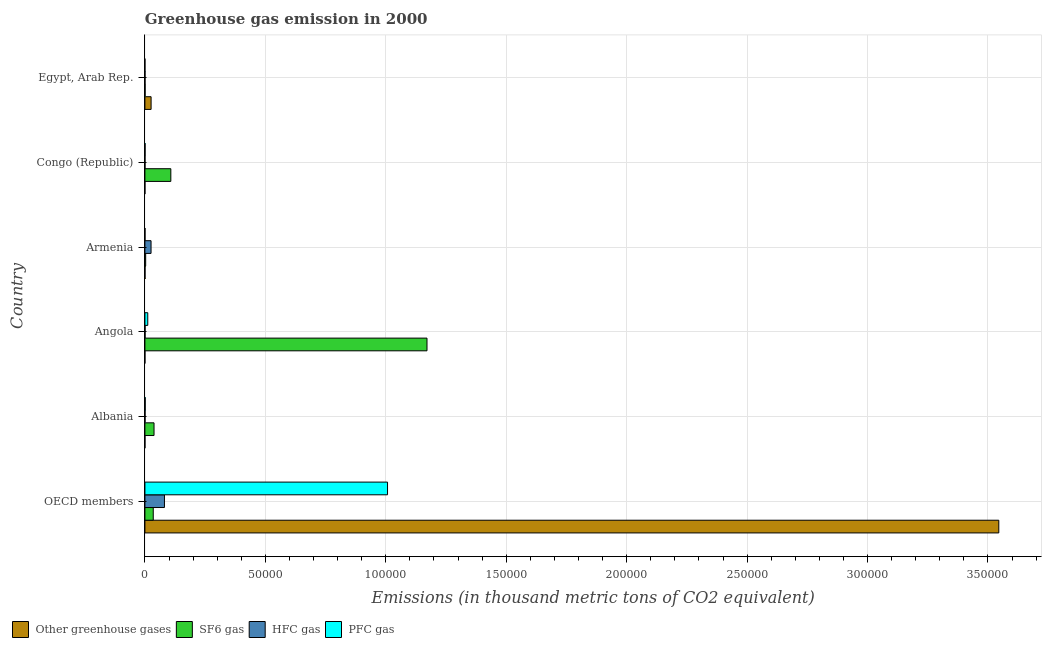How many different coloured bars are there?
Your answer should be very brief. 4. How many groups of bars are there?
Make the answer very short. 6. What is the label of the 4th group of bars from the top?
Give a very brief answer. Angola. What is the emission of hfc gas in Angola?
Offer a very short reply. 63. Across all countries, what is the maximum emission of greenhouse gases?
Your response must be concise. 3.54e+05. Across all countries, what is the minimum emission of sf6 gas?
Your answer should be very brief. 81.4. In which country was the emission of sf6 gas maximum?
Ensure brevity in your answer.  Angola. In which country was the emission of hfc gas minimum?
Make the answer very short. Congo (Republic). What is the total emission of hfc gas in the graph?
Give a very brief answer. 1.08e+04. What is the difference between the emission of hfc gas in Armenia and that in OECD members?
Offer a terse response. -5561.5. What is the difference between the emission of greenhouse gases in Angola and the emission of hfc gas in Egypt, Arab Rep.?
Your response must be concise. -40.7. What is the average emission of sf6 gas per country?
Offer a terse response. 2.26e+04. What is the difference between the emission of pfc gas and emission of hfc gas in Angola?
Offer a terse response. 1118.4. What is the ratio of the emission of sf6 gas in Armenia to that in Congo (Republic)?
Offer a very short reply. 0.03. Is the emission of hfc gas in Angola less than that in Congo (Republic)?
Give a very brief answer. No. Is the difference between the emission of pfc gas in Egypt, Arab Rep. and OECD members greater than the difference between the emission of sf6 gas in Egypt, Arab Rep. and OECD members?
Give a very brief answer. No. What is the difference between the highest and the second highest emission of sf6 gas?
Give a very brief answer. 1.06e+05. What is the difference between the highest and the lowest emission of sf6 gas?
Keep it short and to the point. 1.17e+05. In how many countries, is the emission of greenhouse gases greater than the average emission of greenhouse gases taken over all countries?
Provide a short and direct response. 1. Is the sum of the emission of sf6 gas in Congo (Republic) and Egypt, Arab Rep. greater than the maximum emission of hfc gas across all countries?
Your response must be concise. Yes. What does the 3rd bar from the top in Congo (Republic) represents?
Offer a very short reply. SF6 gas. What does the 4th bar from the bottom in Angola represents?
Provide a short and direct response. PFC gas. Is it the case that in every country, the sum of the emission of greenhouse gases and emission of sf6 gas is greater than the emission of hfc gas?
Offer a terse response. No. How many bars are there?
Provide a succinct answer. 24. Are the values on the major ticks of X-axis written in scientific E-notation?
Offer a very short reply. No. Does the graph contain any zero values?
Give a very brief answer. No. Does the graph contain grids?
Give a very brief answer. Yes. What is the title of the graph?
Give a very brief answer. Greenhouse gas emission in 2000. What is the label or title of the X-axis?
Keep it short and to the point. Emissions (in thousand metric tons of CO2 equivalent). What is the Emissions (in thousand metric tons of CO2 equivalent) in Other greenhouse gases in OECD members?
Your response must be concise. 3.54e+05. What is the Emissions (in thousand metric tons of CO2 equivalent) of SF6 gas in OECD members?
Offer a terse response. 3457.7. What is the Emissions (in thousand metric tons of CO2 equivalent) of HFC gas in OECD members?
Make the answer very short. 8107.2. What is the Emissions (in thousand metric tons of CO2 equivalent) in PFC gas in OECD members?
Make the answer very short. 1.01e+05. What is the Emissions (in thousand metric tons of CO2 equivalent) in SF6 gas in Albania?
Your answer should be compact. 3781.9. What is the Emissions (in thousand metric tons of CO2 equivalent) of HFC gas in Albania?
Your response must be concise. 60.5. What is the Emissions (in thousand metric tons of CO2 equivalent) in PFC gas in Albania?
Provide a succinct answer. 121.8. What is the Emissions (in thousand metric tons of CO2 equivalent) in Other greenhouse gases in Angola?
Offer a very short reply. 0.7. What is the Emissions (in thousand metric tons of CO2 equivalent) of SF6 gas in Angola?
Your response must be concise. 1.17e+05. What is the Emissions (in thousand metric tons of CO2 equivalent) in HFC gas in Angola?
Make the answer very short. 63. What is the Emissions (in thousand metric tons of CO2 equivalent) of PFC gas in Angola?
Keep it short and to the point. 1181.4. What is the Emissions (in thousand metric tons of CO2 equivalent) in SF6 gas in Armenia?
Keep it short and to the point. 311.4. What is the Emissions (in thousand metric tons of CO2 equivalent) in HFC gas in Armenia?
Offer a terse response. 2545.7. What is the Emissions (in thousand metric tons of CO2 equivalent) of PFC gas in Armenia?
Ensure brevity in your answer.  32.8. What is the Emissions (in thousand metric tons of CO2 equivalent) in SF6 gas in Congo (Republic)?
Provide a succinct answer. 1.08e+04. What is the Emissions (in thousand metric tons of CO2 equivalent) in HFC gas in Congo (Republic)?
Provide a short and direct response. 25.2. What is the Emissions (in thousand metric tons of CO2 equivalent) of PFC gas in Congo (Republic)?
Offer a very short reply. 63. What is the Emissions (in thousand metric tons of CO2 equivalent) of Other greenhouse gases in Egypt, Arab Rep.?
Your answer should be very brief. 2565.6. What is the Emissions (in thousand metric tons of CO2 equivalent) in SF6 gas in Egypt, Arab Rep.?
Give a very brief answer. 81.4. What is the Emissions (in thousand metric tons of CO2 equivalent) in HFC gas in Egypt, Arab Rep.?
Your answer should be very brief. 41.4. Across all countries, what is the maximum Emissions (in thousand metric tons of CO2 equivalent) of Other greenhouse gases?
Provide a succinct answer. 3.54e+05. Across all countries, what is the maximum Emissions (in thousand metric tons of CO2 equivalent) in SF6 gas?
Provide a succinct answer. 1.17e+05. Across all countries, what is the maximum Emissions (in thousand metric tons of CO2 equivalent) of HFC gas?
Ensure brevity in your answer.  8107.2. Across all countries, what is the maximum Emissions (in thousand metric tons of CO2 equivalent) in PFC gas?
Your response must be concise. 1.01e+05. Across all countries, what is the minimum Emissions (in thousand metric tons of CO2 equivalent) of SF6 gas?
Your answer should be compact. 81.4. Across all countries, what is the minimum Emissions (in thousand metric tons of CO2 equivalent) of HFC gas?
Keep it short and to the point. 25.2. What is the total Emissions (in thousand metric tons of CO2 equivalent) of Other greenhouse gases in the graph?
Offer a terse response. 3.57e+05. What is the total Emissions (in thousand metric tons of CO2 equivalent) in SF6 gas in the graph?
Provide a succinct answer. 1.35e+05. What is the total Emissions (in thousand metric tons of CO2 equivalent) of HFC gas in the graph?
Make the answer very short. 1.08e+04. What is the total Emissions (in thousand metric tons of CO2 equivalent) of PFC gas in the graph?
Give a very brief answer. 1.02e+05. What is the difference between the Emissions (in thousand metric tons of CO2 equivalent) of Other greenhouse gases in OECD members and that in Albania?
Make the answer very short. 3.54e+05. What is the difference between the Emissions (in thousand metric tons of CO2 equivalent) in SF6 gas in OECD members and that in Albania?
Offer a very short reply. -324.2. What is the difference between the Emissions (in thousand metric tons of CO2 equivalent) in HFC gas in OECD members and that in Albania?
Offer a terse response. 8046.7. What is the difference between the Emissions (in thousand metric tons of CO2 equivalent) in PFC gas in OECD members and that in Albania?
Keep it short and to the point. 1.01e+05. What is the difference between the Emissions (in thousand metric tons of CO2 equivalent) of Other greenhouse gases in OECD members and that in Angola?
Give a very brief answer. 3.54e+05. What is the difference between the Emissions (in thousand metric tons of CO2 equivalent) in SF6 gas in OECD members and that in Angola?
Offer a very short reply. -1.14e+05. What is the difference between the Emissions (in thousand metric tons of CO2 equivalent) in HFC gas in OECD members and that in Angola?
Ensure brevity in your answer.  8044.2. What is the difference between the Emissions (in thousand metric tons of CO2 equivalent) in PFC gas in OECD members and that in Angola?
Your answer should be compact. 9.95e+04. What is the difference between the Emissions (in thousand metric tons of CO2 equivalent) in Other greenhouse gases in OECD members and that in Armenia?
Give a very brief answer. 3.54e+05. What is the difference between the Emissions (in thousand metric tons of CO2 equivalent) in SF6 gas in OECD members and that in Armenia?
Keep it short and to the point. 3146.3. What is the difference between the Emissions (in thousand metric tons of CO2 equivalent) of HFC gas in OECD members and that in Armenia?
Give a very brief answer. 5561.5. What is the difference between the Emissions (in thousand metric tons of CO2 equivalent) of PFC gas in OECD members and that in Armenia?
Provide a short and direct response. 1.01e+05. What is the difference between the Emissions (in thousand metric tons of CO2 equivalent) of Other greenhouse gases in OECD members and that in Congo (Republic)?
Give a very brief answer. 3.54e+05. What is the difference between the Emissions (in thousand metric tons of CO2 equivalent) of SF6 gas in OECD members and that in Congo (Republic)?
Your answer should be compact. -7295.9. What is the difference between the Emissions (in thousand metric tons of CO2 equivalent) in HFC gas in OECD members and that in Congo (Republic)?
Your answer should be very brief. 8082. What is the difference between the Emissions (in thousand metric tons of CO2 equivalent) in PFC gas in OECD members and that in Congo (Republic)?
Offer a very short reply. 1.01e+05. What is the difference between the Emissions (in thousand metric tons of CO2 equivalent) in Other greenhouse gases in OECD members and that in Egypt, Arab Rep.?
Offer a very short reply. 3.52e+05. What is the difference between the Emissions (in thousand metric tons of CO2 equivalent) in SF6 gas in OECD members and that in Egypt, Arab Rep.?
Offer a very short reply. 3376.3. What is the difference between the Emissions (in thousand metric tons of CO2 equivalent) in HFC gas in OECD members and that in Egypt, Arab Rep.?
Keep it short and to the point. 8065.8. What is the difference between the Emissions (in thousand metric tons of CO2 equivalent) in PFC gas in OECD members and that in Egypt, Arab Rep.?
Give a very brief answer. 1.01e+05. What is the difference between the Emissions (in thousand metric tons of CO2 equivalent) of SF6 gas in Albania and that in Angola?
Give a very brief answer. -1.13e+05. What is the difference between the Emissions (in thousand metric tons of CO2 equivalent) of PFC gas in Albania and that in Angola?
Make the answer very short. -1059.6. What is the difference between the Emissions (in thousand metric tons of CO2 equivalent) of Other greenhouse gases in Albania and that in Armenia?
Your answer should be compact. -26.5. What is the difference between the Emissions (in thousand metric tons of CO2 equivalent) in SF6 gas in Albania and that in Armenia?
Give a very brief answer. 3470.5. What is the difference between the Emissions (in thousand metric tons of CO2 equivalent) of HFC gas in Albania and that in Armenia?
Keep it short and to the point. -2485.2. What is the difference between the Emissions (in thousand metric tons of CO2 equivalent) in PFC gas in Albania and that in Armenia?
Keep it short and to the point. 89. What is the difference between the Emissions (in thousand metric tons of CO2 equivalent) in SF6 gas in Albania and that in Congo (Republic)?
Your answer should be very brief. -6971.7. What is the difference between the Emissions (in thousand metric tons of CO2 equivalent) of HFC gas in Albania and that in Congo (Republic)?
Keep it short and to the point. 35.3. What is the difference between the Emissions (in thousand metric tons of CO2 equivalent) in PFC gas in Albania and that in Congo (Republic)?
Give a very brief answer. 58.8. What is the difference between the Emissions (in thousand metric tons of CO2 equivalent) in Other greenhouse gases in Albania and that in Egypt, Arab Rep.?
Keep it short and to the point. -2550.1. What is the difference between the Emissions (in thousand metric tons of CO2 equivalent) in SF6 gas in Albania and that in Egypt, Arab Rep.?
Make the answer very short. 3700.5. What is the difference between the Emissions (in thousand metric tons of CO2 equivalent) of PFC gas in Albania and that in Egypt, Arab Rep.?
Offer a terse response. 118.3. What is the difference between the Emissions (in thousand metric tons of CO2 equivalent) in Other greenhouse gases in Angola and that in Armenia?
Ensure brevity in your answer.  -41.3. What is the difference between the Emissions (in thousand metric tons of CO2 equivalent) of SF6 gas in Angola and that in Armenia?
Provide a short and direct response. 1.17e+05. What is the difference between the Emissions (in thousand metric tons of CO2 equivalent) in HFC gas in Angola and that in Armenia?
Make the answer very short. -2482.7. What is the difference between the Emissions (in thousand metric tons of CO2 equivalent) of PFC gas in Angola and that in Armenia?
Provide a short and direct response. 1148.6. What is the difference between the Emissions (in thousand metric tons of CO2 equivalent) of SF6 gas in Angola and that in Congo (Republic)?
Your answer should be very brief. 1.06e+05. What is the difference between the Emissions (in thousand metric tons of CO2 equivalent) in HFC gas in Angola and that in Congo (Republic)?
Ensure brevity in your answer.  37.8. What is the difference between the Emissions (in thousand metric tons of CO2 equivalent) of PFC gas in Angola and that in Congo (Republic)?
Make the answer very short. 1118.4. What is the difference between the Emissions (in thousand metric tons of CO2 equivalent) in Other greenhouse gases in Angola and that in Egypt, Arab Rep.?
Provide a succinct answer. -2564.9. What is the difference between the Emissions (in thousand metric tons of CO2 equivalent) in SF6 gas in Angola and that in Egypt, Arab Rep.?
Give a very brief answer. 1.17e+05. What is the difference between the Emissions (in thousand metric tons of CO2 equivalent) of HFC gas in Angola and that in Egypt, Arab Rep.?
Your answer should be very brief. 21.6. What is the difference between the Emissions (in thousand metric tons of CO2 equivalent) in PFC gas in Angola and that in Egypt, Arab Rep.?
Your response must be concise. 1177.9. What is the difference between the Emissions (in thousand metric tons of CO2 equivalent) in Other greenhouse gases in Armenia and that in Congo (Republic)?
Ensure brevity in your answer.  41.2. What is the difference between the Emissions (in thousand metric tons of CO2 equivalent) of SF6 gas in Armenia and that in Congo (Republic)?
Offer a terse response. -1.04e+04. What is the difference between the Emissions (in thousand metric tons of CO2 equivalent) of HFC gas in Armenia and that in Congo (Republic)?
Offer a terse response. 2520.5. What is the difference between the Emissions (in thousand metric tons of CO2 equivalent) of PFC gas in Armenia and that in Congo (Republic)?
Make the answer very short. -30.2. What is the difference between the Emissions (in thousand metric tons of CO2 equivalent) of Other greenhouse gases in Armenia and that in Egypt, Arab Rep.?
Your answer should be very brief. -2523.6. What is the difference between the Emissions (in thousand metric tons of CO2 equivalent) of SF6 gas in Armenia and that in Egypt, Arab Rep.?
Your answer should be compact. 230. What is the difference between the Emissions (in thousand metric tons of CO2 equivalent) in HFC gas in Armenia and that in Egypt, Arab Rep.?
Offer a very short reply. 2504.3. What is the difference between the Emissions (in thousand metric tons of CO2 equivalent) of PFC gas in Armenia and that in Egypt, Arab Rep.?
Ensure brevity in your answer.  29.3. What is the difference between the Emissions (in thousand metric tons of CO2 equivalent) in Other greenhouse gases in Congo (Republic) and that in Egypt, Arab Rep.?
Provide a succinct answer. -2564.8. What is the difference between the Emissions (in thousand metric tons of CO2 equivalent) of SF6 gas in Congo (Republic) and that in Egypt, Arab Rep.?
Your answer should be compact. 1.07e+04. What is the difference between the Emissions (in thousand metric tons of CO2 equivalent) in HFC gas in Congo (Republic) and that in Egypt, Arab Rep.?
Give a very brief answer. -16.2. What is the difference between the Emissions (in thousand metric tons of CO2 equivalent) in PFC gas in Congo (Republic) and that in Egypt, Arab Rep.?
Provide a succinct answer. 59.5. What is the difference between the Emissions (in thousand metric tons of CO2 equivalent) in Other greenhouse gases in OECD members and the Emissions (in thousand metric tons of CO2 equivalent) in SF6 gas in Albania?
Your response must be concise. 3.51e+05. What is the difference between the Emissions (in thousand metric tons of CO2 equivalent) in Other greenhouse gases in OECD members and the Emissions (in thousand metric tons of CO2 equivalent) in HFC gas in Albania?
Offer a terse response. 3.54e+05. What is the difference between the Emissions (in thousand metric tons of CO2 equivalent) of Other greenhouse gases in OECD members and the Emissions (in thousand metric tons of CO2 equivalent) of PFC gas in Albania?
Make the answer very short. 3.54e+05. What is the difference between the Emissions (in thousand metric tons of CO2 equivalent) of SF6 gas in OECD members and the Emissions (in thousand metric tons of CO2 equivalent) of HFC gas in Albania?
Your answer should be compact. 3397.2. What is the difference between the Emissions (in thousand metric tons of CO2 equivalent) in SF6 gas in OECD members and the Emissions (in thousand metric tons of CO2 equivalent) in PFC gas in Albania?
Your answer should be compact. 3335.9. What is the difference between the Emissions (in thousand metric tons of CO2 equivalent) in HFC gas in OECD members and the Emissions (in thousand metric tons of CO2 equivalent) in PFC gas in Albania?
Offer a terse response. 7985.4. What is the difference between the Emissions (in thousand metric tons of CO2 equivalent) of Other greenhouse gases in OECD members and the Emissions (in thousand metric tons of CO2 equivalent) of SF6 gas in Angola?
Your answer should be very brief. 2.37e+05. What is the difference between the Emissions (in thousand metric tons of CO2 equivalent) in Other greenhouse gases in OECD members and the Emissions (in thousand metric tons of CO2 equivalent) in HFC gas in Angola?
Your response must be concise. 3.54e+05. What is the difference between the Emissions (in thousand metric tons of CO2 equivalent) in Other greenhouse gases in OECD members and the Emissions (in thousand metric tons of CO2 equivalent) in PFC gas in Angola?
Keep it short and to the point. 3.53e+05. What is the difference between the Emissions (in thousand metric tons of CO2 equivalent) in SF6 gas in OECD members and the Emissions (in thousand metric tons of CO2 equivalent) in HFC gas in Angola?
Keep it short and to the point. 3394.7. What is the difference between the Emissions (in thousand metric tons of CO2 equivalent) in SF6 gas in OECD members and the Emissions (in thousand metric tons of CO2 equivalent) in PFC gas in Angola?
Your answer should be very brief. 2276.3. What is the difference between the Emissions (in thousand metric tons of CO2 equivalent) of HFC gas in OECD members and the Emissions (in thousand metric tons of CO2 equivalent) of PFC gas in Angola?
Ensure brevity in your answer.  6925.8. What is the difference between the Emissions (in thousand metric tons of CO2 equivalent) in Other greenhouse gases in OECD members and the Emissions (in thousand metric tons of CO2 equivalent) in SF6 gas in Armenia?
Provide a succinct answer. 3.54e+05. What is the difference between the Emissions (in thousand metric tons of CO2 equivalent) in Other greenhouse gases in OECD members and the Emissions (in thousand metric tons of CO2 equivalent) in HFC gas in Armenia?
Your answer should be very brief. 3.52e+05. What is the difference between the Emissions (in thousand metric tons of CO2 equivalent) in Other greenhouse gases in OECD members and the Emissions (in thousand metric tons of CO2 equivalent) in PFC gas in Armenia?
Make the answer very short. 3.54e+05. What is the difference between the Emissions (in thousand metric tons of CO2 equivalent) in SF6 gas in OECD members and the Emissions (in thousand metric tons of CO2 equivalent) in HFC gas in Armenia?
Your response must be concise. 912. What is the difference between the Emissions (in thousand metric tons of CO2 equivalent) of SF6 gas in OECD members and the Emissions (in thousand metric tons of CO2 equivalent) of PFC gas in Armenia?
Provide a succinct answer. 3424.9. What is the difference between the Emissions (in thousand metric tons of CO2 equivalent) in HFC gas in OECD members and the Emissions (in thousand metric tons of CO2 equivalent) in PFC gas in Armenia?
Offer a terse response. 8074.4. What is the difference between the Emissions (in thousand metric tons of CO2 equivalent) in Other greenhouse gases in OECD members and the Emissions (in thousand metric tons of CO2 equivalent) in SF6 gas in Congo (Republic)?
Your answer should be compact. 3.44e+05. What is the difference between the Emissions (in thousand metric tons of CO2 equivalent) in Other greenhouse gases in OECD members and the Emissions (in thousand metric tons of CO2 equivalent) in HFC gas in Congo (Republic)?
Your answer should be very brief. 3.54e+05. What is the difference between the Emissions (in thousand metric tons of CO2 equivalent) of Other greenhouse gases in OECD members and the Emissions (in thousand metric tons of CO2 equivalent) of PFC gas in Congo (Republic)?
Your response must be concise. 3.54e+05. What is the difference between the Emissions (in thousand metric tons of CO2 equivalent) of SF6 gas in OECD members and the Emissions (in thousand metric tons of CO2 equivalent) of HFC gas in Congo (Republic)?
Offer a terse response. 3432.5. What is the difference between the Emissions (in thousand metric tons of CO2 equivalent) in SF6 gas in OECD members and the Emissions (in thousand metric tons of CO2 equivalent) in PFC gas in Congo (Republic)?
Provide a short and direct response. 3394.7. What is the difference between the Emissions (in thousand metric tons of CO2 equivalent) of HFC gas in OECD members and the Emissions (in thousand metric tons of CO2 equivalent) of PFC gas in Congo (Republic)?
Your answer should be compact. 8044.2. What is the difference between the Emissions (in thousand metric tons of CO2 equivalent) in Other greenhouse gases in OECD members and the Emissions (in thousand metric tons of CO2 equivalent) in SF6 gas in Egypt, Arab Rep.?
Your answer should be compact. 3.54e+05. What is the difference between the Emissions (in thousand metric tons of CO2 equivalent) of Other greenhouse gases in OECD members and the Emissions (in thousand metric tons of CO2 equivalent) of HFC gas in Egypt, Arab Rep.?
Offer a terse response. 3.54e+05. What is the difference between the Emissions (in thousand metric tons of CO2 equivalent) of Other greenhouse gases in OECD members and the Emissions (in thousand metric tons of CO2 equivalent) of PFC gas in Egypt, Arab Rep.?
Ensure brevity in your answer.  3.54e+05. What is the difference between the Emissions (in thousand metric tons of CO2 equivalent) of SF6 gas in OECD members and the Emissions (in thousand metric tons of CO2 equivalent) of HFC gas in Egypt, Arab Rep.?
Your answer should be compact. 3416.3. What is the difference between the Emissions (in thousand metric tons of CO2 equivalent) in SF6 gas in OECD members and the Emissions (in thousand metric tons of CO2 equivalent) in PFC gas in Egypt, Arab Rep.?
Provide a short and direct response. 3454.2. What is the difference between the Emissions (in thousand metric tons of CO2 equivalent) in HFC gas in OECD members and the Emissions (in thousand metric tons of CO2 equivalent) in PFC gas in Egypt, Arab Rep.?
Provide a short and direct response. 8103.7. What is the difference between the Emissions (in thousand metric tons of CO2 equivalent) of Other greenhouse gases in Albania and the Emissions (in thousand metric tons of CO2 equivalent) of SF6 gas in Angola?
Provide a succinct answer. -1.17e+05. What is the difference between the Emissions (in thousand metric tons of CO2 equivalent) in Other greenhouse gases in Albania and the Emissions (in thousand metric tons of CO2 equivalent) in HFC gas in Angola?
Your answer should be compact. -47.5. What is the difference between the Emissions (in thousand metric tons of CO2 equivalent) in Other greenhouse gases in Albania and the Emissions (in thousand metric tons of CO2 equivalent) in PFC gas in Angola?
Ensure brevity in your answer.  -1165.9. What is the difference between the Emissions (in thousand metric tons of CO2 equivalent) in SF6 gas in Albania and the Emissions (in thousand metric tons of CO2 equivalent) in HFC gas in Angola?
Your answer should be very brief. 3718.9. What is the difference between the Emissions (in thousand metric tons of CO2 equivalent) in SF6 gas in Albania and the Emissions (in thousand metric tons of CO2 equivalent) in PFC gas in Angola?
Ensure brevity in your answer.  2600.5. What is the difference between the Emissions (in thousand metric tons of CO2 equivalent) in HFC gas in Albania and the Emissions (in thousand metric tons of CO2 equivalent) in PFC gas in Angola?
Your response must be concise. -1120.9. What is the difference between the Emissions (in thousand metric tons of CO2 equivalent) in Other greenhouse gases in Albania and the Emissions (in thousand metric tons of CO2 equivalent) in SF6 gas in Armenia?
Make the answer very short. -295.9. What is the difference between the Emissions (in thousand metric tons of CO2 equivalent) in Other greenhouse gases in Albania and the Emissions (in thousand metric tons of CO2 equivalent) in HFC gas in Armenia?
Keep it short and to the point. -2530.2. What is the difference between the Emissions (in thousand metric tons of CO2 equivalent) in Other greenhouse gases in Albania and the Emissions (in thousand metric tons of CO2 equivalent) in PFC gas in Armenia?
Your answer should be very brief. -17.3. What is the difference between the Emissions (in thousand metric tons of CO2 equivalent) in SF6 gas in Albania and the Emissions (in thousand metric tons of CO2 equivalent) in HFC gas in Armenia?
Give a very brief answer. 1236.2. What is the difference between the Emissions (in thousand metric tons of CO2 equivalent) in SF6 gas in Albania and the Emissions (in thousand metric tons of CO2 equivalent) in PFC gas in Armenia?
Your response must be concise. 3749.1. What is the difference between the Emissions (in thousand metric tons of CO2 equivalent) of HFC gas in Albania and the Emissions (in thousand metric tons of CO2 equivalent) of PFC gas in Armenia?
Provide a short and direct response. 27.7. What is the difference between the Emissions (in thousand metric tons of CO2 equivalent) in Other greenhouse gases in Albania and the Emissions (in thousand metric tons of CO2 equivalent) in SF6 gas in Congo (Republic)?
Offer a very short reply. -1.07e+04. What is the difference between the Emissions (in thousand metric tons of CO2 equivalent) of Other greenhouse gases in Albania and the Emissions (in thousand metric tons of CO2 equivalent) of HFC gas in Congo (Republic)?
Your answer should be compact. -9.7. What is the difference between the Emissions (in thousand metric tons of CO2 equivalent) in Other greenhouse gases in Albania and the Emissions (in thousand metric tons of CO2 equivalent) in PFC gas in Congo (Republic)?
Provide a short and direct response. -47.5. What is the difference between the Emissions (in thousand metric tons of CO2 equivalent) in SF6 gas in Albania and the Emissions (in thousand metric tons of CO2 equivalent) in HFC gas in Congo (Republic)?
Provide a short and direct response. 3756.7. What is the difference between the Emissions (in thousand metric tons of CO2 equivalent) in SF6 gas in Albania and the Emissions (in thousand metric tons of CO2 equivalent) in PFC gas in Congo (Republic)?
Your answer should be very brief. 3718.9. What is the difference between the Emissions (in thousand metric tons of CO2 equivalent) of HFC gas in Albania and the Emissions (in thousand metric tons of CO2 equivalent) of PFC gas in Congo (Republic)?
Keep it short and to the point. -2.5. What is the difference between the Emissions (in thousand metric tons of CO2 equivalent) in Other greenhouse gases in Albania and the Emissions (in thousand metric tons of CO2 equivalent) in SF6 gas in Egypt, Arab Rep.?
Your response must be concise. -65.9. What is the difference between the Emissions (in thousand metric tons of CO2 equivalent) of Other greenhouse gases in Albania and the Emissions (in thousand metric tons of CO2 equivalent) of HFC gas in Egypt, Arab Rep.?
Your response must be concise. -25.9. What is the difference between the Emissions (in thousand metric tons of CO2 equivalent) in SF6 gas in Albania and the Emissions (in thousand metric tons of CO2 equivalent) in HFC gas in Egypt, Arab Rep.?
Keep it short and to the point. 3740.5. What is the difference between the Emissions (in thousand metric tons of CO2 equivalent) in SF6 gas in Albania and the Emissions (in thousand metric tons of CO2 equivalent) in PFC gas in Egypt, Arab Rep.?
Offer a terse response. 3778.4. What is the difference between the Emissions (in thousand metric tons of CO2 equivalent) of Other greenhouse gases in Angola and the Emissions (in thousand metric tons of CO2 equivalent) of SF6 gas in Armenia?
Offer a terse response. -310.7. What is the difference between the Emissions (in thousand metric tons of CO2 equivalent) in Other greenhouse gases in Angola and the Emissions (in thousand metric tons of CO2 equivalent) in HFC gas in Armenia?
Your answer should be compact. -2545. What is the difference between the Emissions (in thousand metric tons of CO2 equivalent) in Other greenhouse gases in Angola and the Emissions (in thousand metric tons of CO2 equivalent) in PFC gas in Armenia?
Provide a short and direct response. -32.1. What is the difference between the Emissions (in thousand metric tons of CO2 equivalent) of SF6 gas in Angola and the Emissions (in thousand metric tons of CO2 equivalent) of HFC gas in Armenia?
Offer a very short reply. 1.15e+05. What is the difference between the Emissions (in thousand metric tons of CO2 equivalent) of SF6 gas in Angola and the Emissions (in thousand metric tons of CO2 equivalent) of PFC gas in Armenia?
Ensure brevity in your answer.  1.17e+05. What is the difference between the Emissions (in thousand metric tons of CO2 equivalent) in HFC gas in Angola and the Emissions (in thousand metric tons of CO2 equivalent) in PFC gas in Armenia?
Offer a very short reply. 30.2. What is the difference between the Emissions (in thousand metric tons of CO2 equivalent) in Other greenhouse gases in Angola and the Emissions (in thousand metric tons of CO2 equivalent) in SF6 gas in Congo (Republic)?
Your answer should be compact. -1.08e+04. What is the difference between the Emissions (in thousand metric tons of CO2 equivalent) in Other greenhouse gases in Angola and the Emissions (in thousand metric tons of CO2 equivalent) in HFC gas in Congo (Republic)?
Offer a very short reply. -24.5. What is the difference between the Emissions (in thousand metric tons of CO2 equivalent) in Other greenhouse gases in Angola and the Emissions (in thousand metric tons of CO2 equivalent) in PFC gas in Congo (Republic)?
Your response must be concise. -62.3. What is the difference between the Emissions (in thousand metric tons of CO2 equivalent) in SF6 gas in Angola and the Emissions (in thousand metric tons of CO2 equivalent) in HFC gas in Congo (Republic)?
Your answer should be compact. 1.17e+05. What is the difference between the Emissions (in thousand metric tons of CO2 equivalent) in SF6 gas in Angola and the Emissions (in thousand metric tons of CO2 equivalent) in PFC gas in Congo (Republic)?
Your response must be concise. 1.17e+05. What is the difference between the Emissions (in thousand metric tons of CO2 equivalent) of HFC gas in Angola and the Emissions (in thousand metric tons of CO2 equivalent) of PFC gas in Congo (Republic)?
Keep it short and to the point. 0. What is the difference between the Emissions (in thousand metric tons of CO2 equivalent) of Other greenhouse gases in Angola and the Emissions (in thousand metric tons of CO2 equivalent) of SF6 gas in Egypt, Arab Rep.?
Provide a short and direct response. -80.7. What is the difference between the Emissions (in thousand metric tons of CO2 equivalent) of Other greenhouse gases in Angola and the Emissions (in thousand metric tons of CO2 equivalent) of HFC gas in Egypt, Arab Rep.?
Your answer should be very brief. -40.7. What is the difference between the Emissions (in thousand metric tons of CO2 equivalent) of Other greenhouse gases in Angola and the Emissions (in thousand metric tons of CO2 equivalent) of PFC gas in Egypt, Arab Rep.?
Your answer should be very brief. -2.8. What is the difference between the Emissions (in thousand metric tons of CO2 equivalent) of SF6 gas in Angola and the Emissions (in thousand metric tons of CO2 equivalent) of HFC gas in Egypt, Arab Rep.?
Keep it short and to the point. 1.17e+05. What is the difference between the Emissions (in thousand metric tons of CO2 equivalent) in SF6 gas in Angola and the Emissions (in thousand metric tons of CO2 equivalent) in PFC gas in Egypt, Arab Rep.?
Ensure brevity in your answer.  1.17e+05. What is the difference between the Emissions (in thousand metric tons of CO2 equivalent) of HFC gas in Angola and the Emissions (in thousand metric tons of CO2 equivalent) of PFC gas in Egypt, Arab Rep.?
Ensure brevity in your answer.  59.5. What is the difference between the Emissions (in thousand metric tons of CO2 equivalent) in Other greenhouse gases in Armenia and the Emissions (in thousand metric tons of CO2 equivalent) in SF6 gas in Congo (Republic)?
Provide a short and direct response. -1.07e+04. What is the difference between the Emissions (in thousand metric tons of CO2 equivalent) in Other greenhouse gases in Armenia and the Emissions (in thousand metric tons of CO2 equivalent) in HFC gas in Congo (Republic)?
Make the answer very short. 16.8. What is the difference between the Emissions (in thousand metric tons of CO2 equivalent) in SF6 gas in Armenia and the Emissions (in thousand metric tons of CO2 equivalent) in HFC gas in Congo (Republic)?
Keep it short and to the point. 286.2. What is the difference between the Emissions (in thousand metric tons of CO2 equivalent) of SF6 gas in Armenia and the Emissions (in thousand metric tons of CO2 equivalent) of PFC gas in Congo (Republic)?
Give a very brief answer. 248.4. What is the difference between the Emissions (in thousand metric tons of CO2 equivalent) of HFC gas in Armenia and the Emissions (in thousand metric tons of CO2 equivalent) of PFC gas in Congo (Republic)?
Your answer should be very brief. 2482.7. What is the difference between the Emissions (in thousand metric tons of CO2 equivalent) of Other greenhouse gases in Armenia and the Emissions (in thousand metric tons of CO2 equivalent) of SF6 gas in Egypt, Arab Rep.?
Ensure brevity in your answer.  -39.4. What is the difference between the Emissions (in thousand metric tons of CO2 equivalent) in Other greenhouse gases in Armenia and the Emissions (in thousand metric tons of CO2 equivalent) in HFC gas in Egypt, Arab Rep.?
Offer a very short reply. 0.6. What is the difference between the Emissions (in thousand metric tons of CO2 equivalent) in Other greenhouse gases in Armenia and the Emissions (in thousand metric tons of CO2 equivalent) in PFC gas in Egypt, Arab Rep.?
Your answer should be compact. 38.5. What is the difference between the Emissions (in thousand metric tons of CO2 equivalent) in SF6 gas in Armenia and the Emissions (in thousand metric tons of CO2 equivalent) in HFC gas in Egypt, Arab Rep.?
Provide a short and direct response. 270. What is the difference between the Emissions (in thousand metric tons of CO2 equivalent) of SF6 gas in Armenia and the Emissions (in thousand metric tons of CO2 equivalent) of PFC gas in Egypt, Arab Rep.?
Ensure brevity in your answer.  307.9. What is the difference between the Emissions (in thousand metric tons of CO2 equivalent) of HFC gas in Armenia and the Emissions (in thousand metric tons of CO2 equivalent) of PFC gas in Egypt, Arab Rep.?
Provide a succinct answer. 2542.2. What is the difference between the Emissions (in thousand metric tons of CO2 equivalent) of Other greenhouse gases in Congo (Republic) and the Emissions (in thousand metric tons of CO2 equivalent) of SF6 gas in Egypt, Arab Rep.?
Provide a short and direct response. -80.6. What is the difference between the Emissions (in thousand metric tons of CO2 equivalent) of Other greenhouse gases in Congo (Republic) and the Emissions (in thousand metric tons of CO2 equivalent) of HFC gas in Egypt, Arab Rep.?
Provide a short and direct response. -40.6. What is the difference between the Emissions (in thousand metric tons of CO2 equivalent) of SF6 gas in Congo (Republic) and the Emissions (in thousand metric tons of CO2 equivalent) of HFC gas in Egypt, Arab Rep.?
Give a very brief answer. 1.07e+04. What is the difference between the Emissions (in thousand metric tons of CO2 equivalent) of SF6 gas in Congo (Republic) and the Emissions (in thousand metric tons of CO2 equivalent) of PFC gas in Egypt, Arab Rep.?
Offer a terse response. 1.08e+04. What is the difference between the Emissions (in thousand metric tons of CO2 equivalent) of HFC gas in Congo (Republic) and the Emissions (in thousand metric tons of CO2 equivalent) of PFC gas in Egypt, Arab Rep.?
Your answer should be compact. 21.7. What is the average Emissions (in thousand metric tons of CO2 equivalent) of Other greenhouse gases per country?
Provide a succinct answer. 5.95e+04. What is the average Emissions (in thousand metric tons of CO2 equivalent) of SF6 gas per country?
Your answer should be compact. 2.26e+04. What is the average Emissions (in thousand metric tons of CO2 equivalent) of HFC gas per country?
Keep it short and to the point. 1807.17. What is the average Emissions (in thousand metric tons of CO2 equivalent) of PFC gas per country?
Offer a very short reply. 1.70e+04. What is the difference between the Emissions (in thousand metric tons of CO2 equivalent) of Other greenhouse gases and Emissions (in thousand metric tons of CO2 equivalent) of SF6 gas in OECD members?
Offer a terse response. 3.51e+05. What is the difference between the Emissions (in thousand metric tons of CO2 equivalent) in Other greenhouse gases and Emissions (in thousand metric tons of CO2 equivalent) in HFC gas in OECD members?
Your response must be concise. 3.46e+05. What is the difference between the Emissions (in thousand metric tons of CO2 equivalent) in Other greenhouse gases and Emissions (in thousand metric tons of CO2 equivalent) in PFC gas in OECD members?
Your response must be concise. 2.54e+05. What is the difference between the Emissions (in thousand metric tons of CO2 equivalent) in SF6 gas and Emissions (in thousand metric tons of CO2 equivalent) in HFC gas in OECD members?
Provide a succinct answer. -4649.5. What is the difference between the Emissions (in thousand metric tons of CO2 equivalent) in SF6 gas and Emissions (in thousand metric tons of CO2 equivalent) in PFC gas in OECD members?
Your response must be concise. -9.73e+04. What is the difference between the Emissions (in thousand metric tons of CO2 equivalent) in HFC gas and Emissions (in thousand metric tons of CO2 equivalent) in PFC gas in OECD members?
Offer a terse response. -9.26e+04. What is the difference between the Emissions (in thousand metric tons of CO2 equivalent) of Other greenhouse gases and Emissions (in thousand metric tons of CO2 equivalent) of SF6 gas in Albania?
Offer a very short reply. -3766.4. What is the difference between the Emissions (in thousand metric tons of CO2 equivalent) in Other greenhouse gases and Emissions (in thousand metric tons of CO2 equivalent) in HFC gas in Albania?
Offer a terse response. -45. What is the difference between the Emissions (in thousand metric tons of CO2 equivalent) of Other greenhouse gases and Emissions (in thousand metric tons of CO2 equivalent) of PFC gas in Albania?
Ensure brevity in your answer.  -106.3. What is the difference between the Emissions (in thousand metric tons of CO2 equivalent) of SF6 gas and Emissions (in thousand metric tons of CO2 equivalent) of HFC gas in Albania?
Your response must be concise. 3721.4. What is the difference between the Emissions (in thousand metric tons of CO2 equivalent) in SF6 gas and Emissions (in thousand metric tons of CO2 equivalent) in PFC gas in Albania?
Offer a terse response. 3660.1. What is the difference between the Emissions (in thousand metric tons of CO2 equivalent) in HFC gas and Emissions (in thousand metric tons of CO2 equivalent) in PFC gas in Albania?
Provide a short and direct response. -61.3. What is the difference between the Emissions (in thousand metric tons of CO2 equivalent) in Other greenhouse gases and Emissions (in thousand metric tons of CO2 equivalent) in SF6 gas in Angola?
Provide a short and direct response. -1.17e+05. What is the difference between the Emissions (in thousand metric tons of CO2 equivalent) of Other greenhouse gases and Emissions (in thousand metric tons of CO2 equivalent) of HFC gas in Angola?
Your answer should be compact. -62.3. What is the difference between the Emissions (in thousand metric tons of CO2 equivalent) in Other greenhouse gases and Emissions (in thousand metric tons of CO2 equivalent) in PFC gas in Angola?
Provide a succinct answer. -1180.7. What is the difference between the Emissions (in thousand metric tons of CO2 equivalent) in SF6 gas and Emissions (in thousand metric tons of CO2 equivalent) in HFC gas in Angola?
Your answer should be very brief. 1.17e+05. What is the difference between the Emissions (in thousand metric tons of CO2 equivalent) in SF6 gas and Emissions (in thousand metric tons of CO2 equivalent) in PFC gas in Angola?
Keep it short and to the point. 1.16e+05. What is the difference between the Emissions (in thousand metric tons of CO2 equivalent) in HFC gas and Emissions (in thousand metric tons of CO2 equivalent) in PFC gas in Angola?
Offer a terse response. -1118.4. What is the difference between the Emissions (in thousand metric tons of CO2 equivalent) in Other greenhouse gases and Emissions (in thousand metric tons of CO2 equivalent) in SF6 gas in Armenia?
Your answer should be compact. -269.4. What is the difference between the Emissions (in thousand metric tons of CO2 equivalent) of Other greenhouse gases and Emissions (in thousand metric tons of CO2 equivalent) of HFC gas in Armenia?
Ensure brevity in your answer.  -2503.7. What is the difference between the Emissions (in thousand metric tons of CO2 equivalent) in SF6 gas and Emissions (in thousand metric tons of CO2 equivalent) in HFC gas in Armenia?
Your response must be concise. -2234.3. What is the difference between the Emissions (in thousand metric tons of CO2 equivalent) in SF6 gas and Emissions (in thousand metric tons of CO2 equivalent) in PFC gas in Armenia?
Make the answer very short. 278.6. What is the difference between the Emissions (in thousand metric tons of CO2 equivalent) of HFC gas and Emissions (in thousand metric tons of CO2 equivalent) of PFC gas in Armenia?
Make the answer very short. 2512.9. What is the difference between the Emissions (in thousand metric tons of CO2 equivalent) in Other greenhouse gases and Emissions (in thousand metric tons of CO2 equivalent) in SF6 gas in Congo (Republic)?
Your answer should be very brief. -1.08e+04. What is the difference between the Emissions (in thousand metric tons of CO2 equivalent) in Other greenhouse gases and Emissions (in thousand metric tons of CO2 equivalent) in HFC gas in Congo (Republic)?
Offer a terse response. -24.4. What is the difference between the Emissions (in thousand metric tons of CO2 equivalent) in Other greenhouse gases and Emissions (in thousand metric tons of CO2 equivalent) in PFC gas in Congo (Republic)?
Ensure brevity in your answer.  -62.2. What is the difference between the Emissions (in thousand metric tons of CO2 equivalent) in SF6 gas and Emissions (in thousand metric tons of CO2 equivalent) in HFC gas in Congo (Republic)?
Offer a terse response. 1.07e+04. What is the difference between the Emissions (in thousand metric tons of CO2 equivalent) of SF6 gas and Emissions (in thousand metric tons of CO2 equivalent) of PFC gas in Congo (Republic)?
Offer a very short reply. 1.07e+04. What is the difference between the Emissions (in thousand metric tons of CO2 equivalent) of HFC gas and Emissions (in thousand metric tons of CO2 equivalent) of PFC gas in Congo (Republic)?
Your answer should be compact. -37.8. What is the difference between the Emissions (in thousand metric tons of CO2 equivalent) of Other greenhouse gases and Emissions (in thousand metric tons of CO2 equivalent) of SF6 gas in Egypt, Arab Rep.?
Make the answer very short. 2484.2. What is the difference between the Emissions (in thousand metric tons of CO2 equivalent) in Other greenhouse gases and Emissions (in thousand metric tons of CO2 equivalent) in HFC gas in Egypt, Arab Rep.?
Your answer should be very brief. 2524.2. What is the difference between the Emissions (in thousand metric tons of CO2 equivalent) in Other greenhouse gases and Emissions (in thousand metric tons of CO2 equivalent) in PFC gas in Egypt, Arab Rep.?
Offer a very short reply. 2562.1. What is the difference between the Emissions (in thousand metric tons of CO2 equivalent) of SF6 gas and Emissions (in thousand metric tons of CO2 equivalent) of PFC gas in Egypt, Arab Rep.?
Offer a terse response. 77.9. What is the difference between the Emissions (in thousand metric tons of CO2 equivalent) in HFC gas and Emissions (in thousand metric tons of CO2 equivalent) in PFC gas in Egypt, Arab Rep.?
Your response must be concise. 37.9. What is the ratio of the Emissions (in thousand metric tons of CO2 equivalent) of Other greenhouse gases in OECD members to that in Albania?
Your answer should be very brief. 2.29e+04. What is the ratio of the Emissions (in thousand metric tons of CO2 equivalent) of SF6 gas in OECD members to that in Albania?
Give a very brief answer. 0.91. What is the ratio of the Emissions (in thousand metric tons of CO2 equivalent) in HFC gas in OECD members to that in Albania?
Your answer should be very brief. 134. What is the ratio of the Emissions (in thousand metric tons of CO2 equivalent) in PFC gas in OECD members to that in Albania?
Make the answer very short. 826.91. What is the ratio of the Emissions (in thousand metric tons of CO2 equivalent) in Other greenhouse gases in OECD members to that in Angola?
Ensure brevity in your answer.  5.06e+05. What is the ratio of the Emissions (in thousand metric tons of CO2 equivalent) in SF6 gas in OECD members to that in Angola?
Ensure brevity in your answer.  0.03. What is the ratio of the Emissions (in thousand metric tons of CO2 equivalent) of HFC gas in OECD members to that in Angola?
Your answer should be compact. 128.69. What is the ratio of the Emissions (in thousand metric tons of CO2 equivalent) in PFC gas in OECD members to that in Angola?
Ensure brevity in your answer.  85.25. What is the ratio of the Emissions (in thousand metric tons of CO2 equivalent) in Other greenhouse gases in OECD members to that in Armenia?
Give a very brief answer. 8440.15. What is the ratio of the Emissions (in thousand metric tons of CO2 equivalent) of SF6 gas in OECD members to that in Armenia?
Provide a short and direct response. 11.1. What is the ratio of the Emissions (in thousand metric tons of CO2 equivalent) of HFC gas in OECD members to that in Armenia?
Provide a short and direct response. 3.18. What is the ratio of the Emissions (in thousand metric tons of CO2 equivalent) in PFC gas in OECD members to that in Armenia?
Your response must be concise. 3070.66. What is the ratio of the Emissions (in thousand metric tons of CO2 equivalent) of Other greenhouse gases in OECD members to that in Congo (Republic)?
Offer a terse response. 4.43e+05. What is the ratio of the Emissions (in thousand metric tons of CO2 equivalent) in SF6 gas in OECD members to that in Congo (Republic)?
Offer a terse response. 0.32. What is the ratio of the Emissions (in thousand metric tons of CO2 equivalent) in HFC gas in OECD members to that in Congo (Republic)?
Keep it short and to the point. 321.71. What is the ratio of the Emissions (in thousand metric tons of CO2 equivalent) of PFC gas in OECD members to that in Congo (Republic)?
Make the answer very short. 1598.7. What is the ratio of the Emissions (in thousand metric tons of CO2 equivalent) of Other greenhouse gases in OECD members to that in Egypt, Arab Rep.?
Provide a succinct answer. 138.17. What is the ratio of the Emissions (in thousand metric tons of CO2 equivalent) of SF6 gas in OECD members to that in Egypt, Arab Rep.?
Make the answer very short. 42.48. What is the ratio of the Emissions (in thousand metric tons of CO2 equivalent) of HFC gas in OECD members to that in Egypt, Arab Rep.?
Provide a succinct answer. 195.83. What is the ratio of the Emissions (in thousand metric tons of CO2 equivalent) in PFC gas in OECD members to that in Egypt, Arab Rep.?
Keep it short and to the point. 2.88e+04. What is the ratio of the Emissions (in thousand metric tons of CO2 equivalent) of Other greenhouse gases in Albania to that in Angola?
Make the answer very short. 22.14. What is the ratio of the Emissions (in thousand metric tons of CO2 equivalent) in SF6 gas in Albania to that in Angola?
Provide a short and direct response. 0.03. What is the ratio of the Emissions (in thousand metric tons of CO2 equivalent) of HFC gas in Albania to that in Angola?
Provide a short and direct response. 0.96. What is the ratio of the Emissions (in thousand metric tons of CO2 equivalent) of PFC gas in Albania to that in Angola?
Provide a short and direct response. 0.1. What is the ratio of the Emissions (in thousand metric tons of CO2 equivalent) in Other greenhouse gases in Albania to that in Armenia?
Give a very brief answer. 0.37. What is the ratio of the Emissions (in thousand metric tons of CO2 equivalent) in SF6 gas in Albania to that in Armenia?
Your answer should be very brief. 12.14. What is the ratio of the Emissions (in thousand metric tons of CO2 equivalent) in HFC gas in Albania to that in Armenia?
Make the answer very short. 0.02. What is the ratio of the Emissions (in thousand metric tons of CO2 equivalent) of PFC gas in Albania to that in Armenia?
Provide a short and direct response. 3.71. What is the ratio of the Emissions (in thousand metric tons of CO2 equivalent) of Other greenhouse gases in Albania to that in Congo (Republic)?
Offer a very short reply. 19.38. What is the ratio of the Emissions (in thousand metric tons of CO2 equivalent) of SF6 gas in Albania to that in Congo (Republic)?
Your answer should be very brief. 0.35. What is the ratio of the Emissions (in thousand metric tons of CO2 equivalent) of HFC gas in Albania to that in Congo (Republic)?
Offer a very short reply. 2.4. What is the ratio of the Emissions (in thousand metric tons of CO2 equivalent) in PFC gas in Albania to that in Congo (Republic)?
Provide a succinct answer. 1.93. What is the ratio of the Emissions (in thousand metric tons of CO2 equivalent) of Other greenhouse gases in Albania to that in Egypt, Arab Rep.?
Your answer should be compact. 0.01. What is the ratio of the Emissions (in thousand metric tons of CO2 equivalent) of SF6 gas in Albania to that in Egypt, Arab Rep.?
Make the answer very short. 46.46. What is the ratio of the Emissions (in thousand metric tons of CO2 equivalent) of HFC gas in Albania to that in Egypt, Arab Rep.?
Ensure brevity in your answer.  1.46. What is the ratio of the Emissions (in thousand metric tons of CO2 equivalent) of PFC gas in Albania to that in Egypt, Arab Rep.?
Your response must be concise. 34.8. What is the ratio of the Emissions (in thousand metric tons of CO2 equivalent) in Other greenhouse gases in Angola to that in Armenia?
Offer a terse response. 0.02. What is the ratio of the Emissions (in thousand metric tons of CO2 equivalent) of SF6 gas in Angola to that in Armenia?
Offer a very short reply. 376.06. What is the ratio of the Emissions (in thousand metric tons of CO2 equivalent) in HFC gas in Angola to that in Armenia?
Keep it short and to the point. 0.02. What is the ratio of the Emissions (in thousand metric tons of CO2 equivalent) in PFC gas in Angola to that in Armenia?
Make the answer very short. 36.02. What is the ratio of the Emissions (in thousand metric tons of CO2 equivalent) in SF6 gas in Angola to that in Congo (Republic)?
Make the answer very short. 10.89. What is the ratio of the Emissions (in thousand metric tons of CO2 equivalent) in HFC gas in Angola to that in Congo (Republic)?
Your response must be concise. 2.5. What is the ratio of the Emissions (in thousand metric tons of CO2 equivalent) of PFC gas in Angola to that in Congo (Republic)?
Provide a short and direct response. 18.75. What is the ratio of the Emissions (in thousand metric tons of CO2 equivalent) in SF6 gas in Angola to that in Egypt, Arab Rep.?
Offer a terse response. 1438.62. What is the ratio of the Emissions (in thousand metric tons of CO2 equivalent) of HFC gas in Angola to that in Egypt, Arab Rep.?
Provide a succinct answer. 1.52. What is the ratio of the Emissions (in thousand metric tons of CO2 equivalent) of PFC gas in Angola to that in Egypt, Arab Rep.?
Ensure brevity in your answer.  337.54. What is the ratio of the Emissions (in thousand metric tons of CO2 equivalent) of Other greenhouse gases in Armenia to that in Congo (Republic)?
Offer a terse response. 52.5. What is the ratio of the Emissions (in thousand metric tons of CO2 equivalent) in SF6 gas in Armenia to that in Congo (Republic)?
Offer a terse response. 0.03. What is the ratio of the Emissions (in thousand metric tons of CO2 equivalent) of HFC gas in Armenia to that in Congo (Republic)?
Your response must be concise. 101.02. What is the ratio of the Emissions (in thousand metric tons of CO2 equivalent) of PFC gas in Armenia to that in Congo (Republic)?
Your answer should be compact. 0.52. What is the ratio of the Emissions (in thousand metric tons of CO2 equivalent) of Other greenhouse gases in Armenia to that in Egypt, Arab Rep.?
Offer a terse response. 0.02. What is the ratio of the Emissions (in thousand metric tons of CO2 equivalent) of SF6 gas in Armenia to that in Egypt, Arab Rep.?
Give a very brief answer. 3.83. What is the ratio of the Emissions (in thousand metric tons of CO2 equivalent) in HFC gas in Armenia to that in Egypt, Arab Rep.?
Make the answer very short. 61.49. What is the ratio of the Emissions (in thousand metric tons of CO2 equivalent) in PFC gas in Armenia to that in Egypt, Arab Rep.?
Keep it short and to the point. 9.37. What is the ratio of the Emissions (in thousand metric tons of CO2 equivalent) in SF6 gas in Congo (Republic) to that in Egypt, Arab Rep.?
Your answer should be compact. 132.11. What is the ratio of the Emissions (in thousand metric tons of CO2 equivalent) of HFC gas in Congo (Republic) to that in Egypt, Arab Rep.?
Offer a terse response. 0.61. What is the difference between the highest and the second highest Emissions (in thousand metric tons of CO2 equivalent) of Other greenhouse gases?
Ensure brevity in your answer.  3.52e+05. What is the difference between the highest and the second highest Emissions (in thousand metric tons of CO2 equivalent) in SF6 gas?
Keep it short and to the point. 1.06e+05. What is the difference between the highest and the second highest Emissions (in thousand metric tons of CO2 equivalent) of HFC gas?
Make the answer very short. 5561.5. What is the difference between the highest and the second highest Emissions (in thousand metric tons of CO2 equivalent) in PFC gas?
Keep it short and to the point. 9.95e+04. What is the difference between the highest and the lowest Emissions (in thousand metric tons of CO2 equivalent) in Other greenhouse gases?
Your answer should be compact. 3.54e+05. What is the difference between the highest and the lowest Emissions (in thousand metric tons of CO2 equivalent) in SF6 gas?
Your answer should be very brief. 1.17e+05. What is the difference between the highest and the lowest Emissions (in thousand metric tons of CO2 equivalent) of HFC gas?
Your answer should be compact. 8082. What is the difference between the highest and the lowest Emissions (in thousand metric tons of CO2 equivalent) of PFC gas?
Your answer should be very brief. 1.01e+05. 